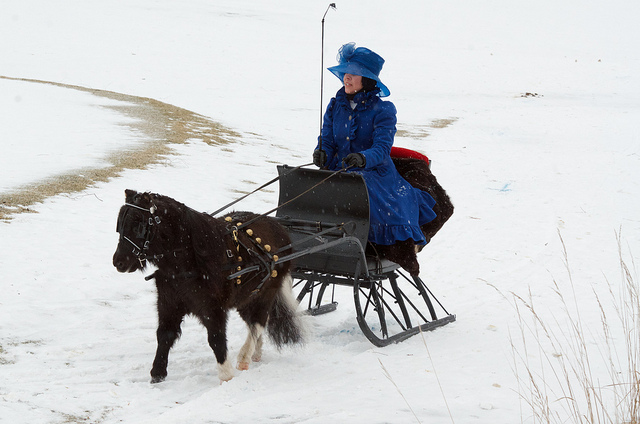Is the horse running? No, the horse is not running. It is walking at a steady pace while pulling a sled through the snow. 